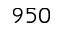Convert formula to latex. <formula><loc_0><loc_0><loc_500><loc_500>9 5 0</formula> 